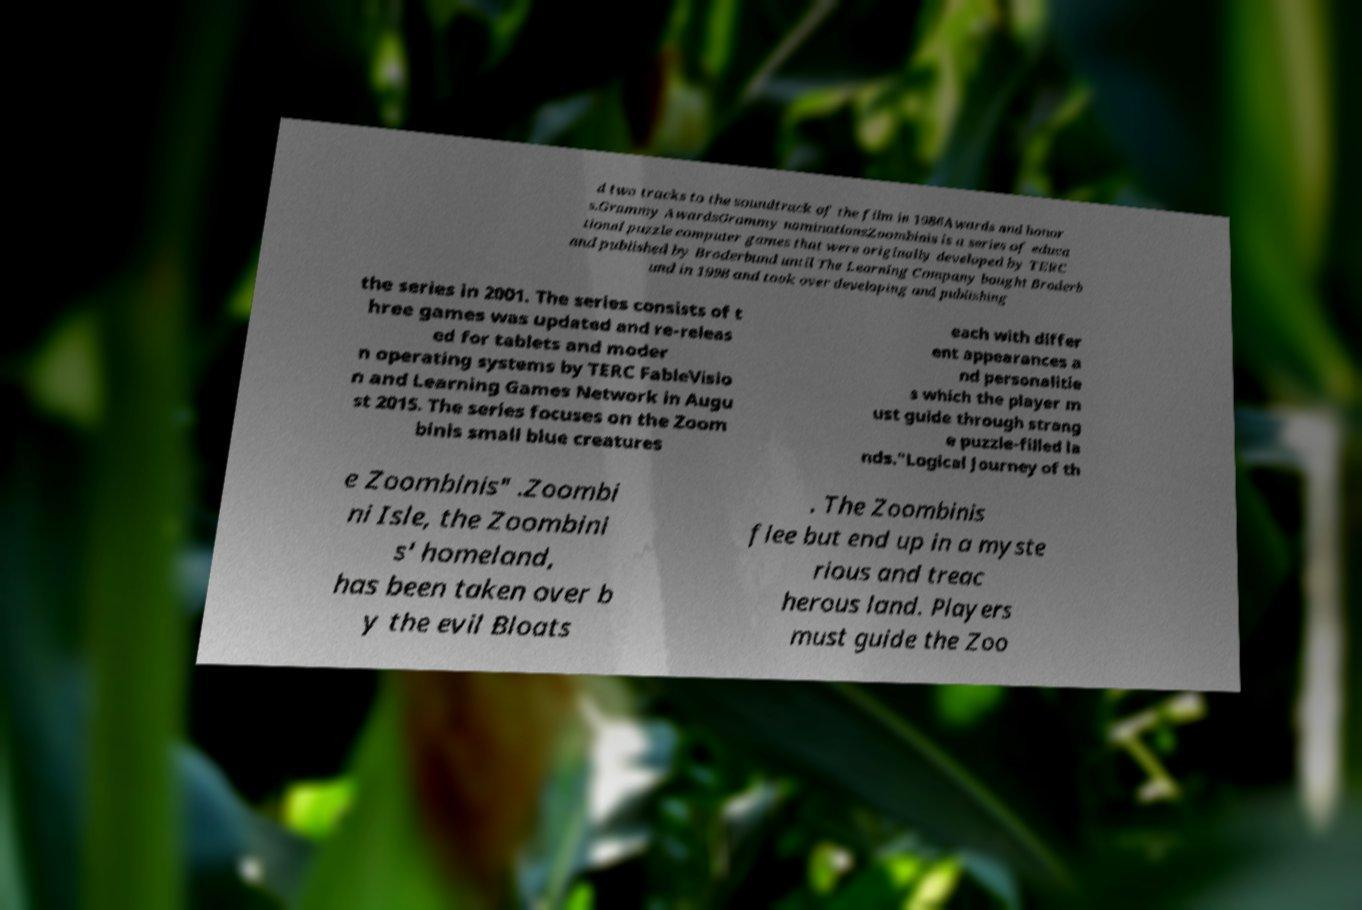Can you accurately transcribe the text from the provided image for me? d two tracks to the soundtrack of the film in 1986Awards and honor s.Grammy AwardsGrammy nominationsZoombinis is a series of educa tional puzzle computer games that were originally developed by TERC and published by Broderbund until The Learning Company bought Broderb und in 1998 and took over developing and publishing the series in 2001. The series consists of t hree games was updated and re-releas ed for tablets and moder n operating systems by TERC FableVisio n and Learning Games Network in Augu st 2015. The series focuses on the Zoom binis small blue creatures each with differ ent appearances a nd personalitie s which the player m ust guide through strang e puzzle-filled la nds."Logical Journey of th e Zoombinis" .Zoombi ni Isle, the Zoombini s' homeland, has been taken over b y the evil Bloats . The Zoombinis flee but end up in a myste rious and treac herous land. Players must guide the Zoo 